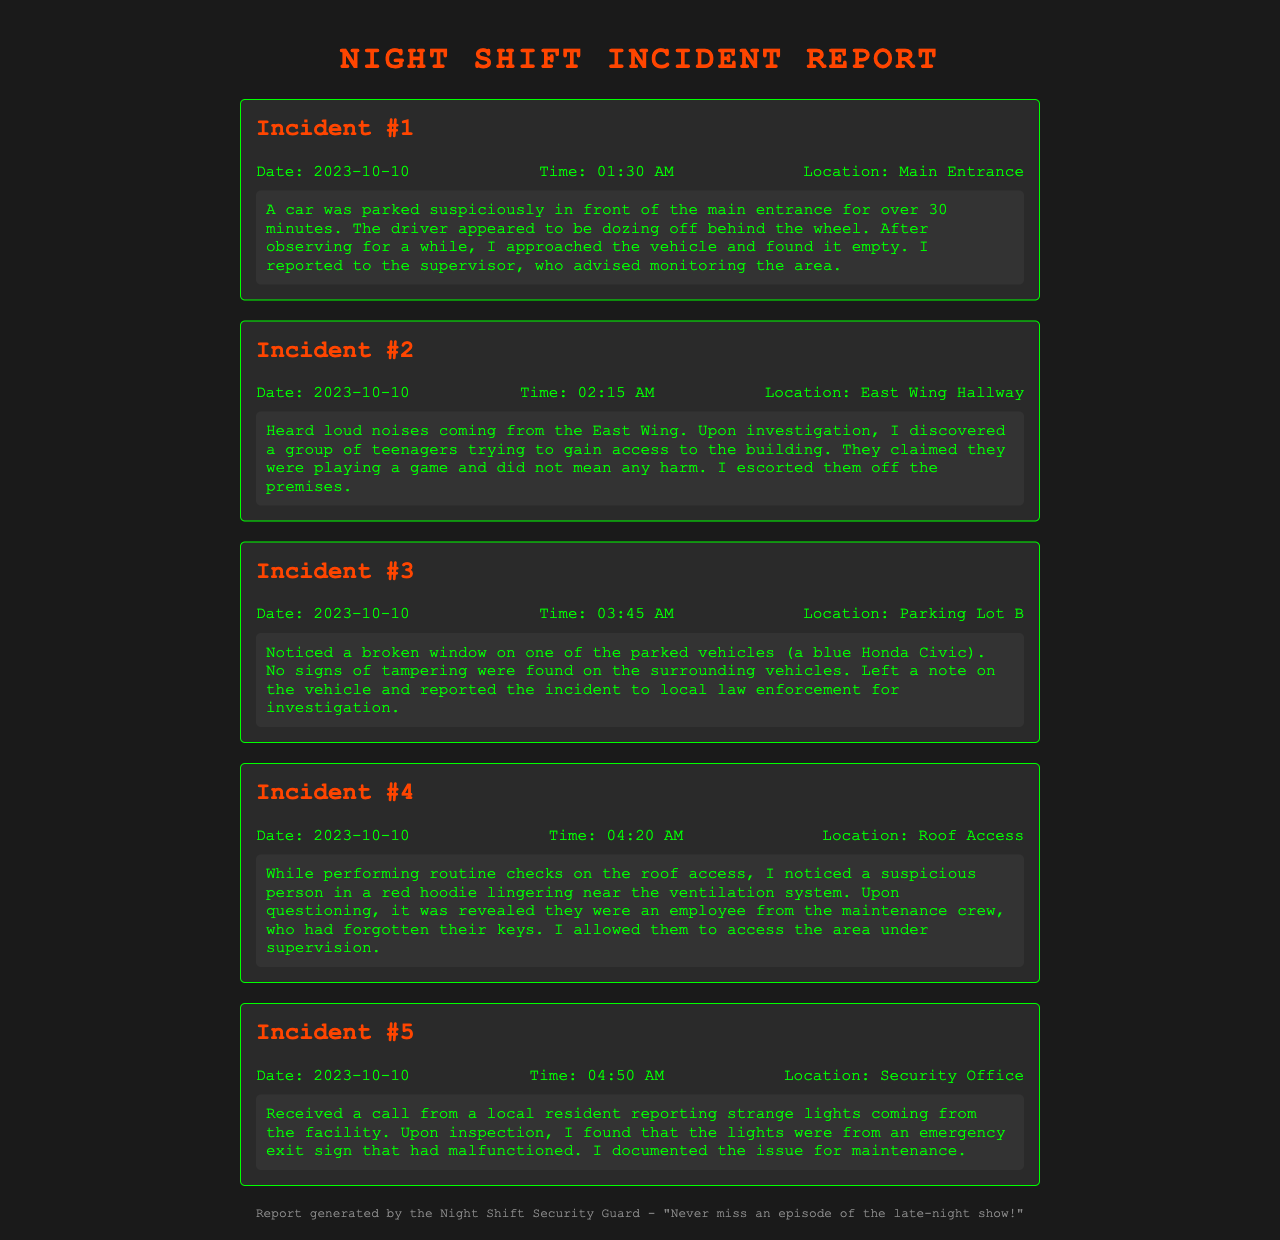What was the date of Incident #1? The document states that Incident #1 occurred on the date mentioned in the incident description, which is 2023-10-10.
Answer: 2023-10-10 What time did the suspicious car incident occur? The specific time for the car parked suspiciously is listed as 01:30 AM in the incident details.
Answer: 01:30 AM Where did the group of teenagers attempt to gain access? According to the document, they were trying to gain access in the East Wing Hallway.
Answer: East Wing Hallway How many incidents were reported in total? The document includes a total of five distinct incidents listed.
Answer: 5 What was the nature of the disturbance reported in Incident #5? The incident report describes the disturbance as strange lights coming from an emergency exit sign.
Answer: Strange lights Which vehicle had a broken window in Incident #3? The report states it was a blue Honda Civic that had a broken window.
Answer: Blue Honda Civic What did the suspicious person in Incident #4 forget? The document indicates that the person forgot their keys, which was clarified during questioning.
Answer: Keys How did the security guard respond to the maintenance crew member? The guard allowed the maintenance crew member access under supervision, as stated in the incident report.
Answer: Under supervision What action was taken regarding the broken window? The report mentions that a note was left on the vehicle and the incident was reported to local law enforcement.
Answer: Left a note and reported to law enforcement 